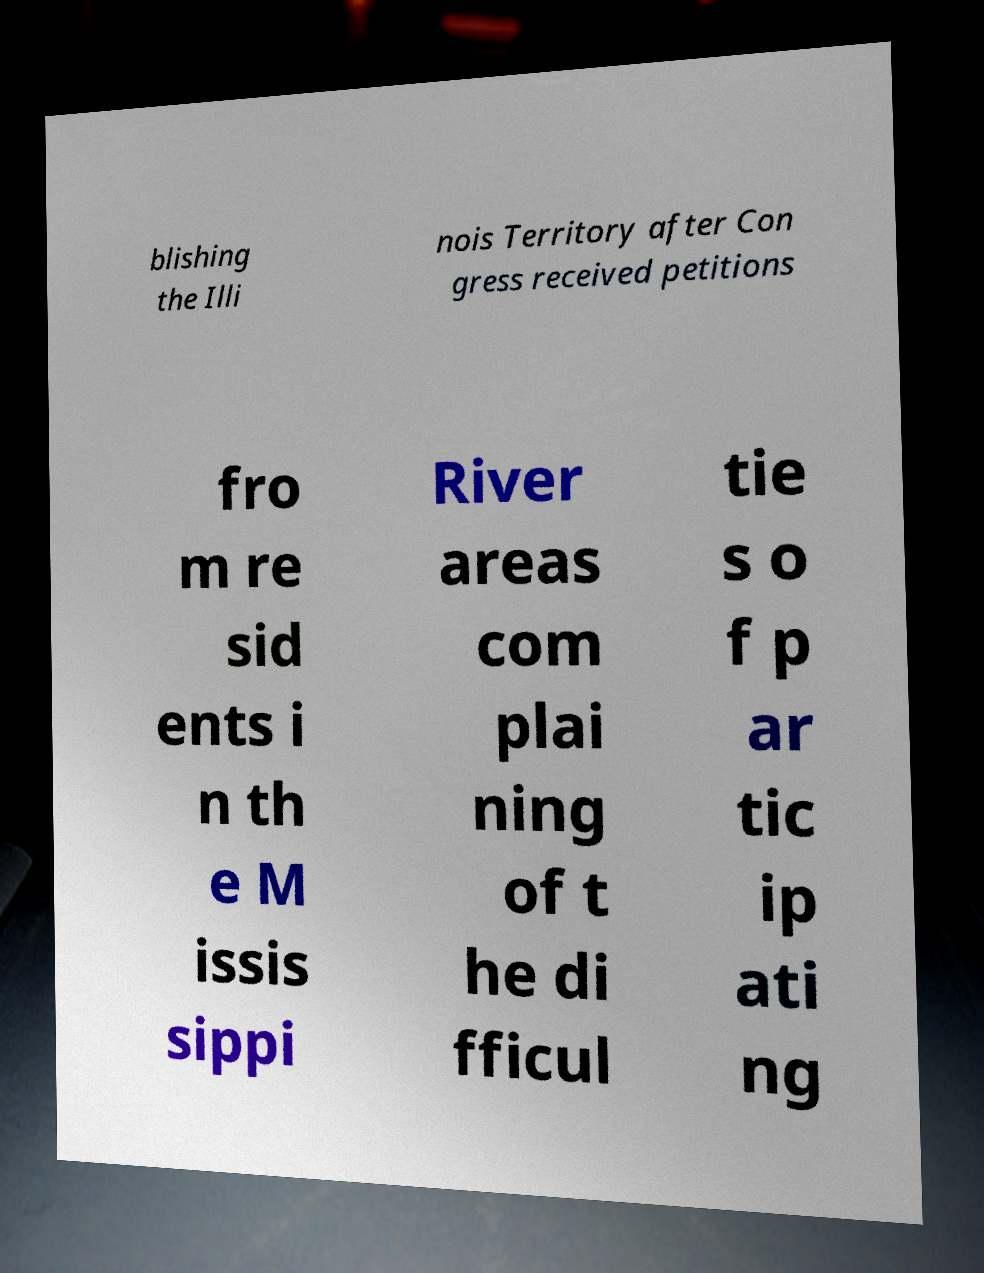Could you assist in decoding the text presented in this image and type it out clearly? blishing the Illi nois Territory after Con gress received petitions fro m re sid ents i n th e M issis sippi River areas com plai ning of t he di fficul tie s o f p ar tic ip ati ng 